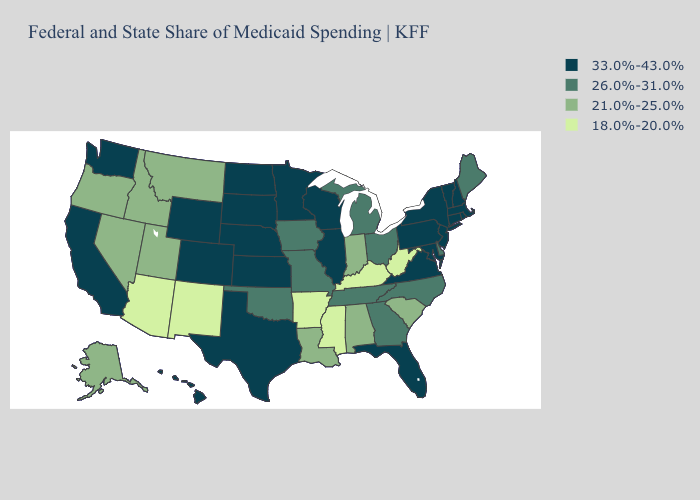Does Michigan have the highest value in the MidWest?
Concise answer only. No. What is the lowest value in states that border New York?
Answer briefly. 33.0%-43.0%. Does New York have the highest value in the Northeast?
Keep it brief. Yes. How many symbols are there in the legend?
Concise answer only. 4. Does the map have missing data?
Write a very short answer. No. Does Minnesota have the highest value in the USA?
Answer briefly. Yes. What is the value of New Mexico?
Give a very brief answer. 18.0%-20.0%. What is the value of Iowa?
Concise answer only. 26.0%-31.0%. Does New Hampshire have the same value as Nebraska?
Write a very short answer. Yes. What is the highest value in states that border Pennsylvania?
Concise answer only. 33.0%-43.0%. What is the highest value in the USA?
Quick response, please. 33.0%-43.0%. What is the highest value in states that border Wyoming?
Answer briefly. 33.0%-43.0%. Name the states that have a value in the range 21.0%-25.0%?
Quick response, please. Alabama, Alaska, Idaho, Indiana, Louisiana, Montana, Nevada, Oregon, South Carolina, Utah. Name the states that have a value in the range 18.0%-20.0%?
Quick response, please. Arizona, Arkansas, Kentucky, Mississippi, New Mexico, West Virginia. How many symbols are there in the legend?
Write a very short answer. 4. 